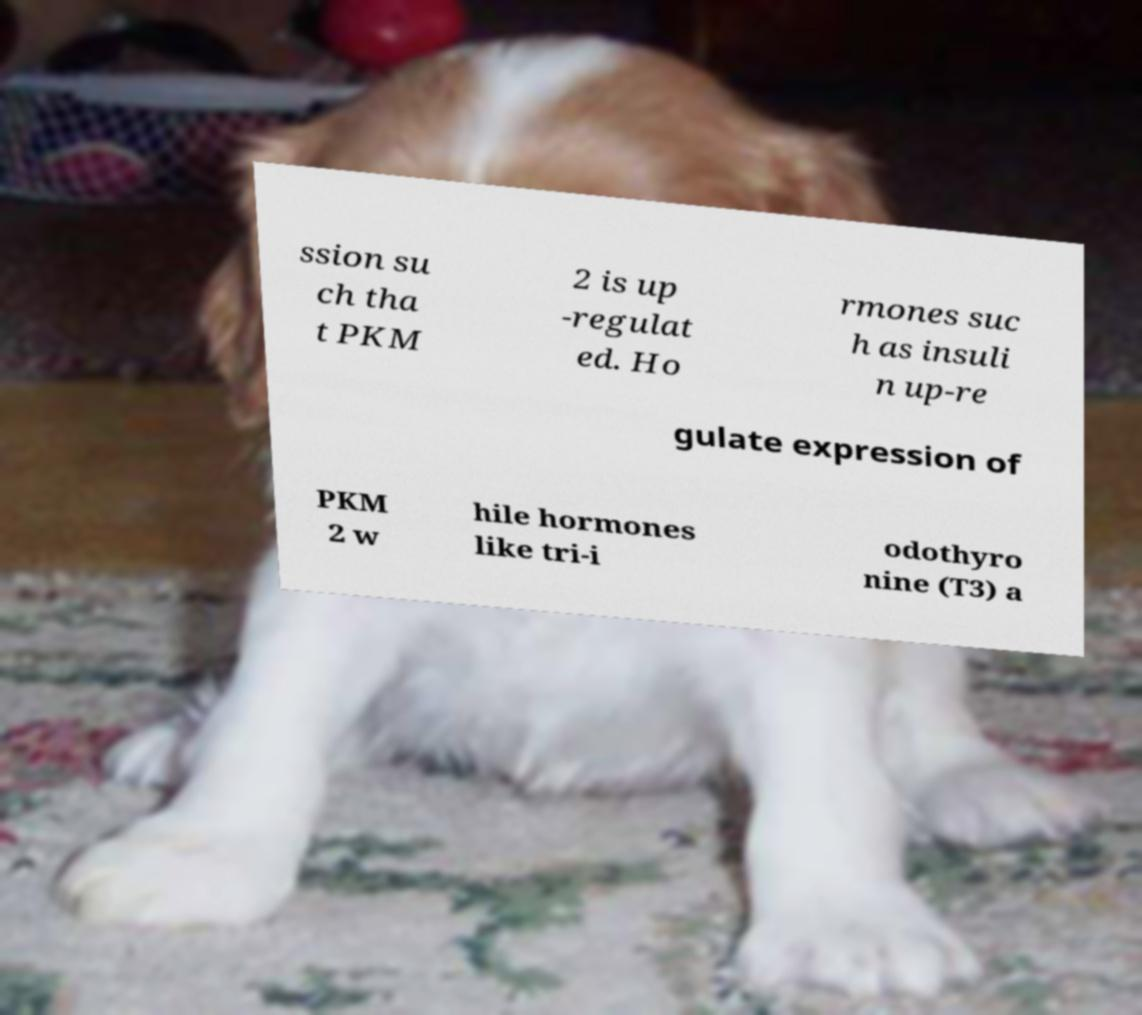Can you accurately transcribe the text from the provided image for me? ssion su ch tha t PKM 2 is up -regulat ed. Ho rmones suc h as insuli n up-re gulate expression of PKM 2 w hile hormones like tri-i odothyro nine (T3) a 